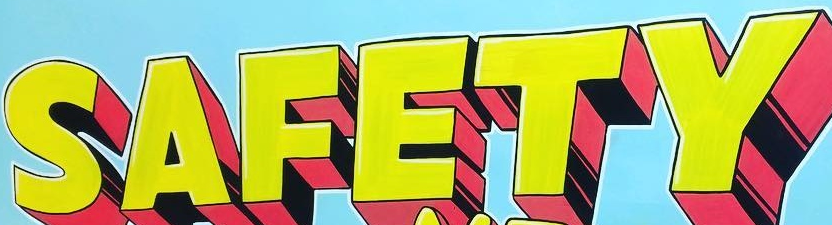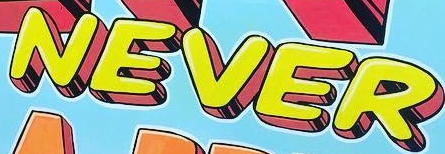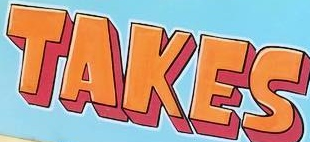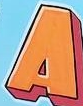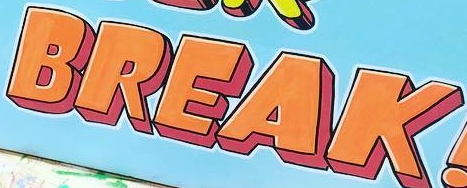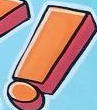Read the text content from these images in order, separated by a semicolon. SAFETY; NEVER; TAKES; A; BREAK; ! 